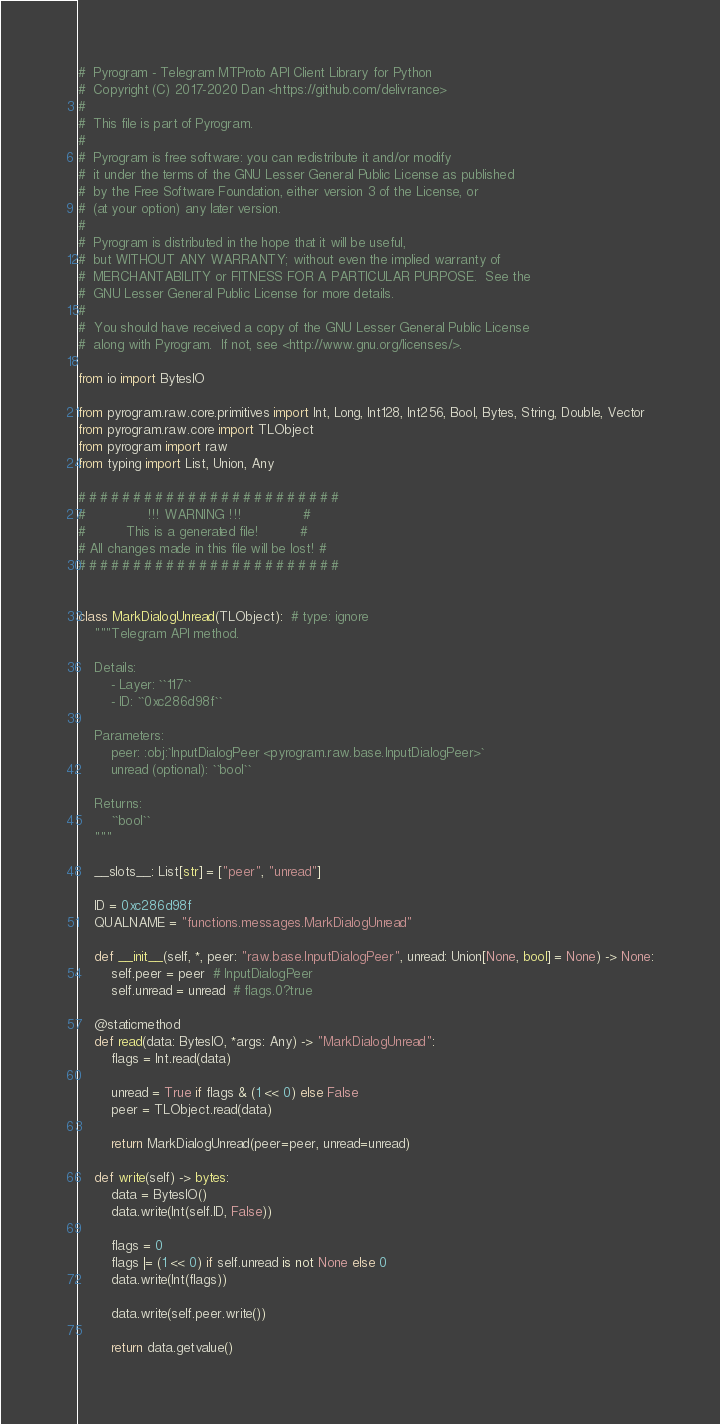<code> <loc_0><loc_0><loc_500><loc_500><_Python_>#  Pyrogram - Telegram MTProto API Client Library for Python
#  Copyright (C) 2017-2020 Dan <https://github.com/delivrance>
#
#  This file is part of Pyrogram.
#
#  Pyrogram is free software: you can redistribute it and/or modify
#  it under the terms of the GNU Lesser General Public License as published
#  by the Free Software Foundation, either version 3 of the License, or
#  (at your option) any later version.
#
#  Pyrogram is distributed in the hope that it will be useful,
#  but WITHOUT ANY WARRANTY; without even the implied warranty of
#  MERCHANTABILITY or FITNESS FOR A PARTICULAR PURPOSE.  See the
#  GNU Lesser General Public License for more details.
#
#  You should have received a copy of the GNU Lesser General Public License
#  along with Pyrogram.  If not, see <http://www.gnu.org/licenses/>.

from io import BytesIO

from pyrogram.raw.core.primitives import Int, Long, Int128, Int256, Bool, Bytes, String, Double, Vector
from pyrogram.raw.core import TLObject
from pyrogram import raw
from typing import List, Union, Any

# # # # # # # # # # # # # # # # # # # # # # # #
#               !!! WARNING !!!               #
#          This is a generated file!          #
# All changes made in this file will be lost! #
# # # # # # # # # # # # # # # # # # # # # # # #


class MarkDialogUnread(TLObject):  # type: ignore
    """Telegram API method.

    Details:
        - Layer: ``117``
        - ID: ``0xc286d98f``

    Parameters:
        peer: :obj:`InputDialogPeer <pyrogram.raw.base.InputDialogPeer>`
        unread (optional): ``bool``

    Returns:
        ``bool``
    """

    __slots__: List[str] = ["peer", "unread"]

    ID = 0xc286d98f
    QUALNAME = "functions.messages.MarkDialogUnread"

    def __init__(self, *, peer: "raw.base.InputDialogPeer", unread: Union[None, bool] = None) -> None:
        self.peer = peer  # InputDialogPeer
        self.unread = unread  # flags.0?true

    @staticmethod
    def read(data: BytesIO, *args: Any) -> "MarkDialogUnread":
        flags = Int.read(data)
        
        unread = True if flags & (1 << 0) else False
        peer = TLObject.read(data)
        
        return MarkDialogUnread(peer=peer, unread=unread)

    def write(self) -> bytes:
        data = BytesIO()
        data.write(Int(self.ID, False))

        flags = 0
        flags |= (1 << 0) if self.unread is not None else 0
        data.write(Int(flags))
        
        data.write(self.peer.write())
        
        return data.getvalue()
</code> 